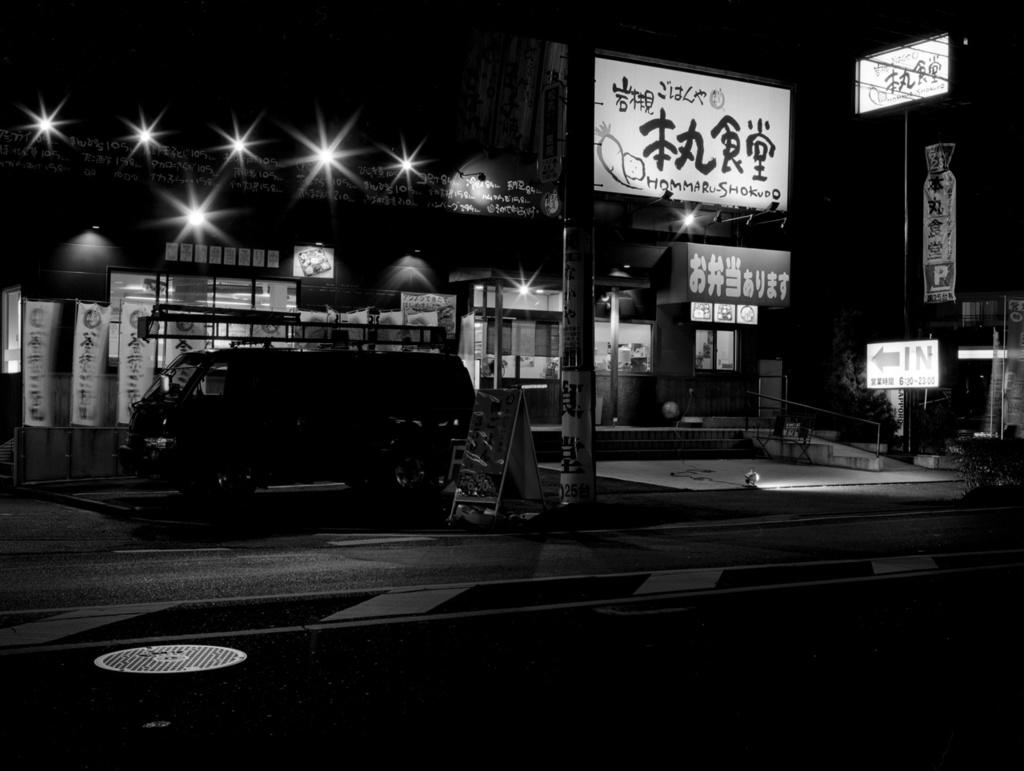What is on the road in the image? There is a vehicle on the road in the image. What can be seen near the road in the image? There is a pole, a poster, electric wires, and stairs in the image. What structure is present in the image? There is a building in the image. What are some additional items visible in the image? There are banners, lights, a plant, and a footpath in the image. What language is the vehicle speaking in the image? Vehicles do not speak languages; they are inanimate objects. 